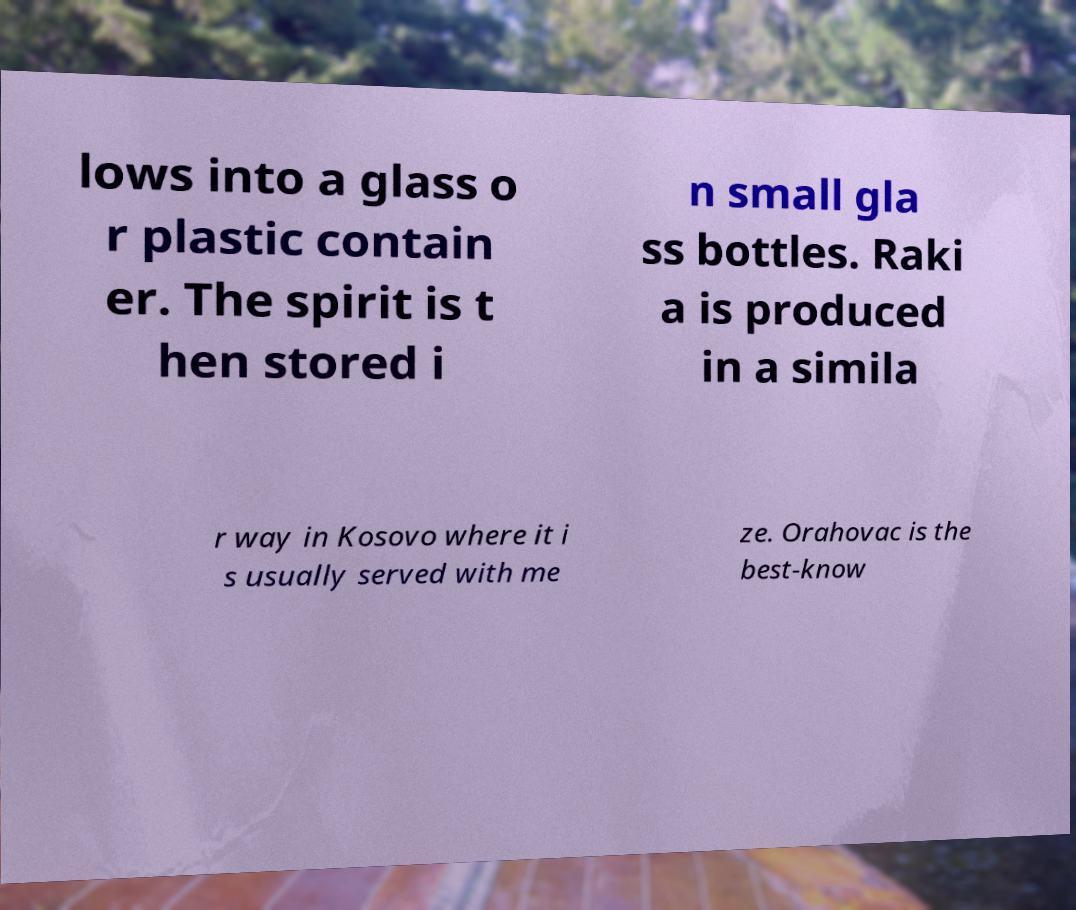There's text embedded in this image that I need extracted. Can you transcribe it verbatim? lows into a glass o r plastic contain er. The spirit is t hen stored i n small gla ss bottles. Raki a is produced in a simila r way in Kosovo where it i s usually served with me ze. Orahovac is the best-know 